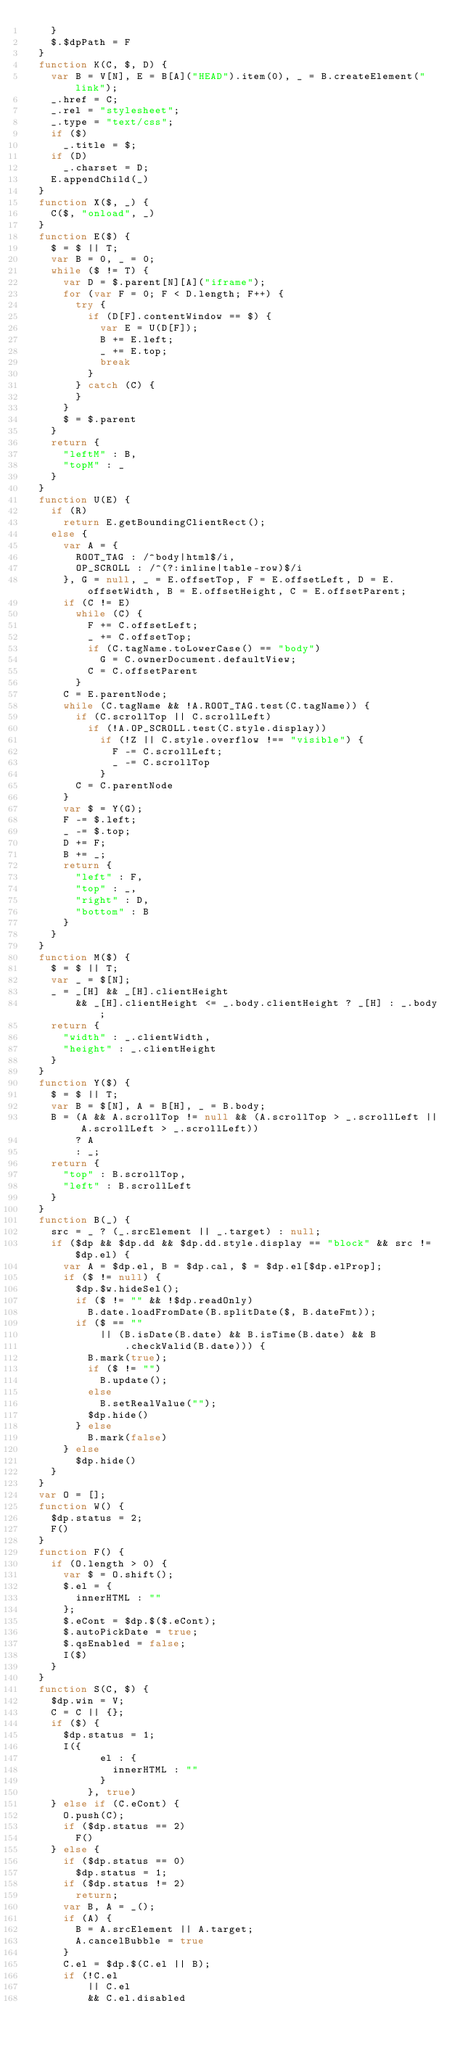<code> <loc_0><loc_0><loc_500><loc_500><_JavaScript_>		}
		$.$dpPath = F
	}
	function K(C, $, D) {
		var B = V[N], E = B[A]("HEAD").item(0), _ = B.createElement("link");
		_.href = C;
		_.rel = "stylesheet";
		_.type = "text/css";
		if ($)
			_.title = $;
		if (D)
			_.charset = D;
		E.appendChild(_)
	}
	function X($, _) {
		C($, "onload", _)
	}
	function E($) {
		$ = $ || T;
		var B = 0, _ = 0;
		while ($ != T) {
			var D = $.parent[N][A]("iframe");
			for (var F = 0; F < D.length; F++) {
				try {
					if (D[F].contentWindow == $) {
						var E = U(D[F]);
						B += E.left;
						_ += E.top;
						break
					}
				} catch (C) {
				}
			}
			$ = $.parent
		}
		return {
			"leftM" : B,
			"topM" : _
		}
	}
	function U(E) {
		if (R)
			return E.getBoundingClientRect();
		else {
			var A = {
				ROOT_TAG : /^body|html$/i,
				OP_SCROLL : /^(?:inline|table-row)$/i
			}, G = null, _ = E.offsetTop, F = E.offsetLeft, D = E.offsetWidth, B = E.offsetHeight, C = E.offsetParent;
			if (C != E)
				while (C) {
					F += C.offsetLeft;
					_ += C.offsetTop;
					if (C.tagName.toLowerCase() == "body")
						G = C.ownerDocument.defaultView;
					C = C.offsetParent
				}
			C = E.parentNode;
			while (C.tagName && !A.ROOT_TAG.test(C.tagName)) {
				if (C.scrollTop || C.scrollLeft)
					if (!A.OP_SCROLL.test(C.style.display))
						if (!Z || C.style.overflow !== "visible") {
							F -= C.scrollLeft;
							_ -= C.scrollTop
						}
				C = C.parentNode
			}
			var $ = Y(G);
			F -= $.left;
			_ -= $.top;
			D += F;
			B += _;
			return {
				"left" : F,
				"top" : _,
				"right" : D,
				"bottom" : B
			}
		}
	}
	function M($) {
		$ = $ || T;
		var _ = $[N];
		_ = _[H] && _[H].clientHeight
				&& _[H].clientHeight <= _.body.clientHeight ? _[H] : _.body;
		return {
			"width" : _.clientWidth,
			"height" : _.clientHeight
		}
	}
	function Y($) {
		$ = $ || T;
		var B = $[N], A = B[H], _ = B.body;
		B = (A && A.scrollTop != null && (A.scrollTop > _.scrollLeft || A.scrollLeft > _.scrollLeft))
				? A
				: _;
		return {
			"top" : B.scrollTop,
			"left" : B.scrollLeft
		}
	}
	function B(_) {
		src = _ ? (_.srcElement || _.target) : null;
		if ($dp && $dp.dd && $dp.dd.style.display == "block" && src != $dp.el) {
			var A = $dp.el, B = $dp.cal, $ = $dp.el[$dp.elProp];
			if ($ != null) {
				$dp.$w.hideSel();
				if ($ != "" && !$dp.readOnly)
					B.date.loadFromDate(B.splitDate($, B.dateFmt));
				if ($ == ""
						|| (B.isDate(B.date) && B.isTime(B.date) && B
								.checkValid(B.date))) {
					B.mark(true);
					if ($ != "")
						B.update();
					else
						B.setRealValue("");
					$dp.hide()
				} else
					B.mark(false)
			} else
				$dp.hide()
		}
	}
	var O = [];
	function W() {
		$dp.status = 2;
		F()
	}
	function F() {
		if (O.length > 0) {
			var $ = O.shift();
			$.el = {
				innerHTML : ""
			};
			$.eCont = $dp.$($.eCont);
			$.autoPickDate = true;
			$.qsEnabled = false;
			I($)
		}
	}
	function S(C, $) {
		$dp.win = V;
		C = C || {};
		if ($) {
			$dp.status = 1;
			I({
						el : {
							innerHTML : ""
						}
					}, true)
		} else if (C.eCont) {
			O.push(C);
			if ($dp.status == 2)
				F()
		} else {
			if ($dp.status == 0)
				$dp.status = 1;
			if ($dp.status != 2)
				return;
			var B, A = _();
			if (A) {
				B = A.srcElement || A.target;
				A.cancelBubble = true
			}
			C.el = $dp.$(C.el || B);
			if (!C.el
					|| C.el
					&& C.el.disabled</code> 